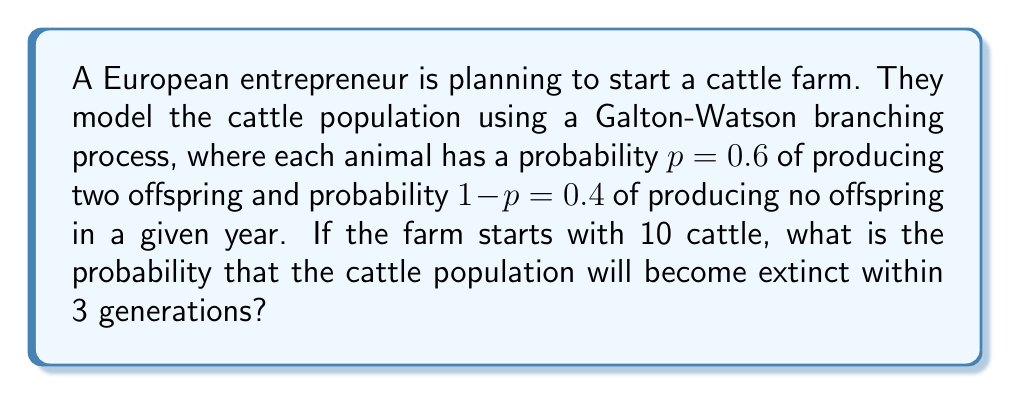Provide a solution to this math problem. To solve this problem, we need to use the properties of Galton-Watson branching processes:

1) Let $q$ be the probability of ultimate extinction. In this case, $q$ satisfies the equation:
   $q = (1-p) + pq^2 = 0.4 + 0.6q^2$

2) Solving this quadratic equation:
   $0.6q^2 - q + 0.4 = 0$
   $(3q-2)(q+1) = 0$
   $q = 2/3$ or $q = -1$ (discard as probability cannot be negative)

3) The probability of extinction by the nth generation is given by:
   $P(\text{extinction by nth generation}) = q_n = q_{n-1}(1-p+pq_{n-1}^2)$
   where $q_0 = 0$ (as we start with a non-zero population)

4) Calculate for 3 generations:
   $q_1 = 0(1-0.6+0.6\cdot0^2) = 0$
   $q_2 = 0(1-0.6+0.6\cdot0^2) = 0$
   $q_3 = 0(1-0.6+0.6\cdot0^2) = 0$

5) The probability of extinction for a single line of descent after 3 generations is 0.

6) For 10 initial cattle, the probability of all lines becoming extinct is:
   $P(\text{extinction of all 10 lines}) = 0^{10} = 0$

Therefore, the probability of the cattle population becoming extinct within 3 generations is 0.
Answer: 0 